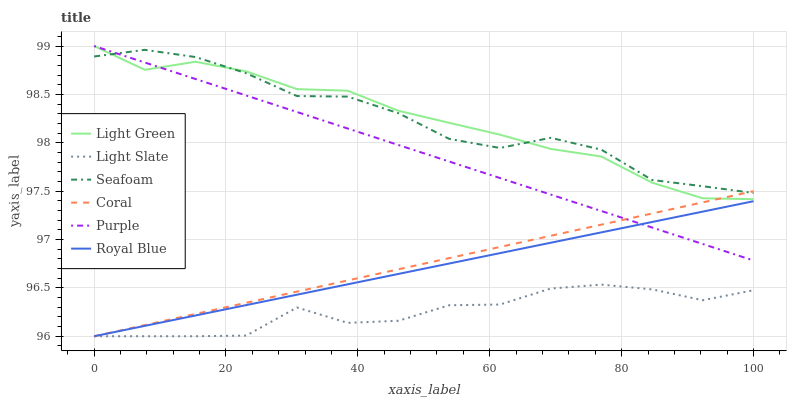Does Light Slate have the minimum area under the curve?
Answer yes or no. Yes. Does Seafoam have the maximum area under the curve?
Answer yes or no. Yes. Does Coral have the minimum area under the curve?
Answer yes or no. No. Does Coral have the maximum area under the curve?
Answer yes or no. No. Is Royal Blue the smoothest?
Answer yes or no. Yes. Is Light Slate the roughest?
Answer yes or no. Yes. Is Coral the smoothest?
Answer yes or no. No. Is Coral the roughest?
Answer yes or no. No. Does Royal Blue have the lowest value?
Answer yes or no. Yes. Does Seafoam have the lowest value?
Answer yes or no. No. Does Light Green have the highest value?
Answer yes or no. Yes. Does Coral have the highest value?
Answer yes or no. No. Is Royal Blue less than Light Green?
Answer yes or no. Yes. Is Light Green greater than Light Slate?
Answer yes or no. Yes. Does Light Slate intersect Royal Blue?
Answer yes or no. Yes. Is Light Slate less than Royal Blue?
Answer yes or no. No. Is Light Slate greater than Royal Blue?
Answer yes or no. No. Does Royal Blue intersect Light Green?
Answer yes or no. No. 